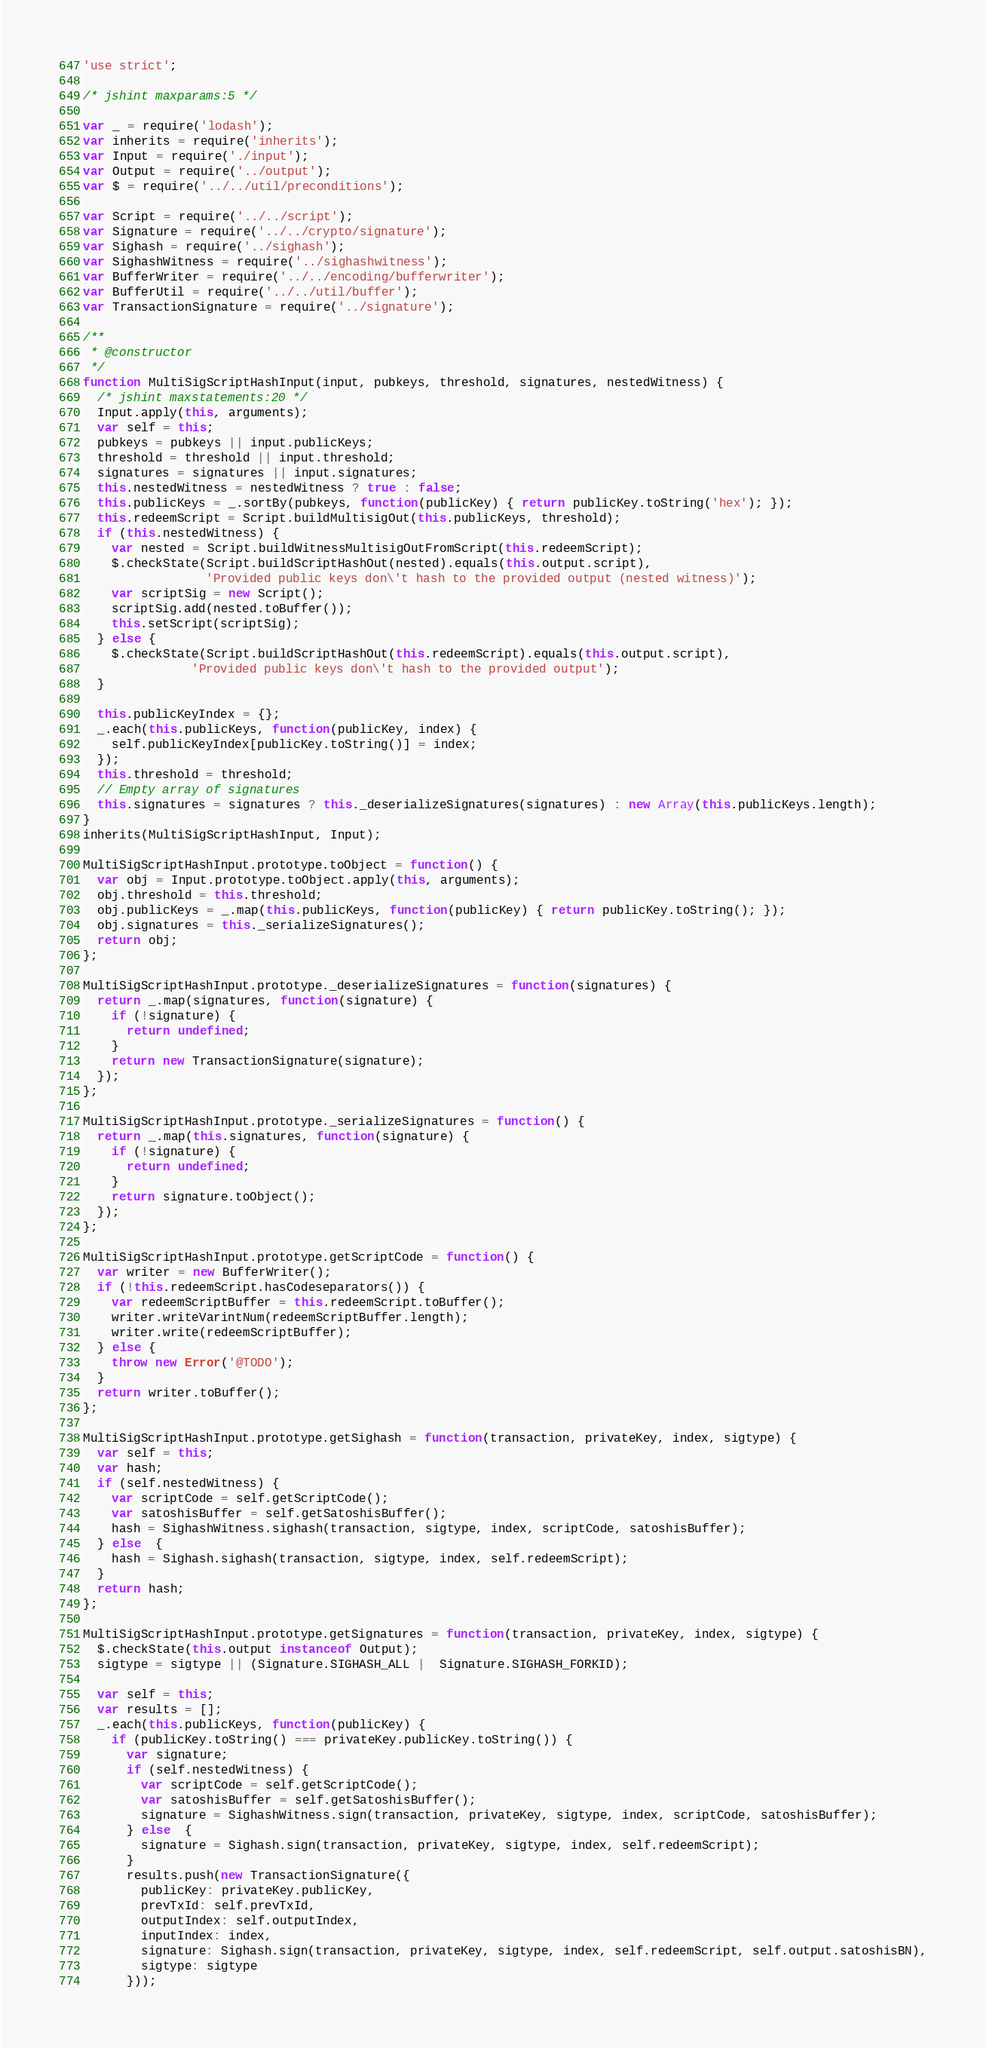<code> <loc_0><loc_0><loc_500><loc_500><_JavaScript_>'use strict';

/* jshint maxparams:5 */

var _ = require('lodash');
var inherits = require('inherits');
var Input = require('./input');
var Output = require('../output');
var $ = require('../../util/preconditions');

var Script = require('../../script');
var Signature = require('../../crypto/signature');
var Sighash = require('../sighash');
var SighashWitness = require('../sighashwitness');
var BufferWriter = require('../../encoding/bufferwriter');
var BufferUtil = require('../../util/buffer');
var TransactionSignature = require('../signature');

/**
 * @constructor
 */
function MultiSigScriptHashInput(input, pubkeys, threshold, signatures, nestedWitness) {
  /* jshint maxstatements:20 */
  Input.apply(this, arguments);
  var self = this;
  pubkeys = pubkeys || input.publicKeys;
  threshold = threshold || input.threshold;
  signatures = signatures || input.signatures;
  this.nestedWitness = nestedWitness ? true : false;
  this.publicKeys = _.sortBy(pubkeys, function(publicKey) { return publicKey.toString('hex'); });
  this.redeemScript = Script.buildMultisigOut(this.publicKeys, threshold);
  if (this.nestedWitness) {
    var nested = Script.buildWitnessMultisigOutFromScript(this.redeemScript);
    $.checkState(Script.buildScriptHashOut(nested).equals(this.output.script),
                 'Provided public keys don\'t hash to the provided output (nested witness)');
    var scriptSig = new Script();
    scriptSig.add(nested.toBuffer());
    this.setScript(scriptSig);
  } else {
    $.checkState(Script.buildScriptHashOut(this.redeemScript).equals(this.output.script),
               'Provided public keys don\'t hash to the provided output');
  }

  this.publicKeyIndex = {};
  _.each(this.publicKeys, function(publicKey, index) {
    self.publicKeyIndex[publicKey.toString()] = index;
  });
  this.threshold = threshold;
  // Empty array of signatures
  this.signatures = signatures ? this._deserializeSignatures(signatures) : new Array(this.publicKeys.length);
}
inherits(MultiSigScriptHashInput, Input);

MultiSigScriptHashInput.prototype.toObject = function() {
  var obj = Input.prototype.toObject.apply(this, arguments);
  obj.threshold = this.threshold;
  obj.publicKeys = _.map(this.publicKeys, function(publicKey) { return publicKey.toString(); });
  obj.signatures = this._serializeSignatures();
  return obj;
};

MultiSigScriptHashInput.prototype._deserializeSignatures = function(signatures) {
  return _.map(signatures, function(signature) {
    if (!signature) {
      return undefined;
    }
    return new TransactionSignature(signature);
  });
};

MultiSigScriptHashInput.prototype._serializeSignatures = function() {
  return _.map(this.signatures, function(signature) {
    if (!signature) {
      return undefined;
    }
    return signature.toObject();
  });
};

MultiSigScriptHashInput.prototype.getScriptCode = function() {
  var writer = new BufferWriter();
  if (!this.redeemScript.hasCodeseparators()) {
    var redeemScriptBuffer = this.redeemScript.toBuffer();
    writer.writeVarintNum(redeemScriptBuffer.length);
    writer.write(redeemScriptBuffer);
  } else {
    throw new Error('@TODO');
  }
  return writer.toBuffer();
};

MultiSigScriptHashInput.prototype.getSighash = function(transaction, privateKey, index, sigtype) {
  var self = this;
  var hash;
  if (self.nestedWitness) {
    var scriptCode = self.getScriptCode();
    var satoshisBuffer = self.getSatoshisBuffer();
    hash = SighashWitness.sighash(transaction, sigtype, index, scriptCode, satoshisBuffer);
  } else  {
    hash = Sighash.sighash(transaction, sigtype, index, self.redeemScript);
  }
  return hash;
};

MultiSigScriptHashInput.prototype.getSignatures = function(transaction, privateKey, index, sigtype) {
  $.checkState(this.output instanceof Output);
  sigtype = sigtype || (Signature.SIGHASH_ALL |  Signature.SIGHASH_FORKID);

  var self = this;
  var results = [];
  _.each(this.publicKeys, function(publicKey) {
    if (publicKey.toString() === privateKey.publicKey.toString()) {
      var signature;
      if (self.nestedWitness) {
        var scriptCode = self.getScriptCode();
        var satoshisBuffer = self.getSatoshisBuffer();
        signature = SighashWitness.sign(transaction, privateKey, sigtype, index, scriptCode, satoshisBuffer);
      } else  {
        signature = Sighash.sign(transaction, privateKey, sigtype, index, self.redeemScript);
      }
      results.push(new TransactionSignature({
        publicKey: privateKey.publicKey,
        prevTxId: self.prevTxId,
        outputIndex: self.outputIndex,
        inputIndex: index,
        signature: Sighash.sign(transaction, privateKey, sigtype, index, self.redeemScript, self.output.satoshisBN),
        sigtype: sigtype
      }));</code> 